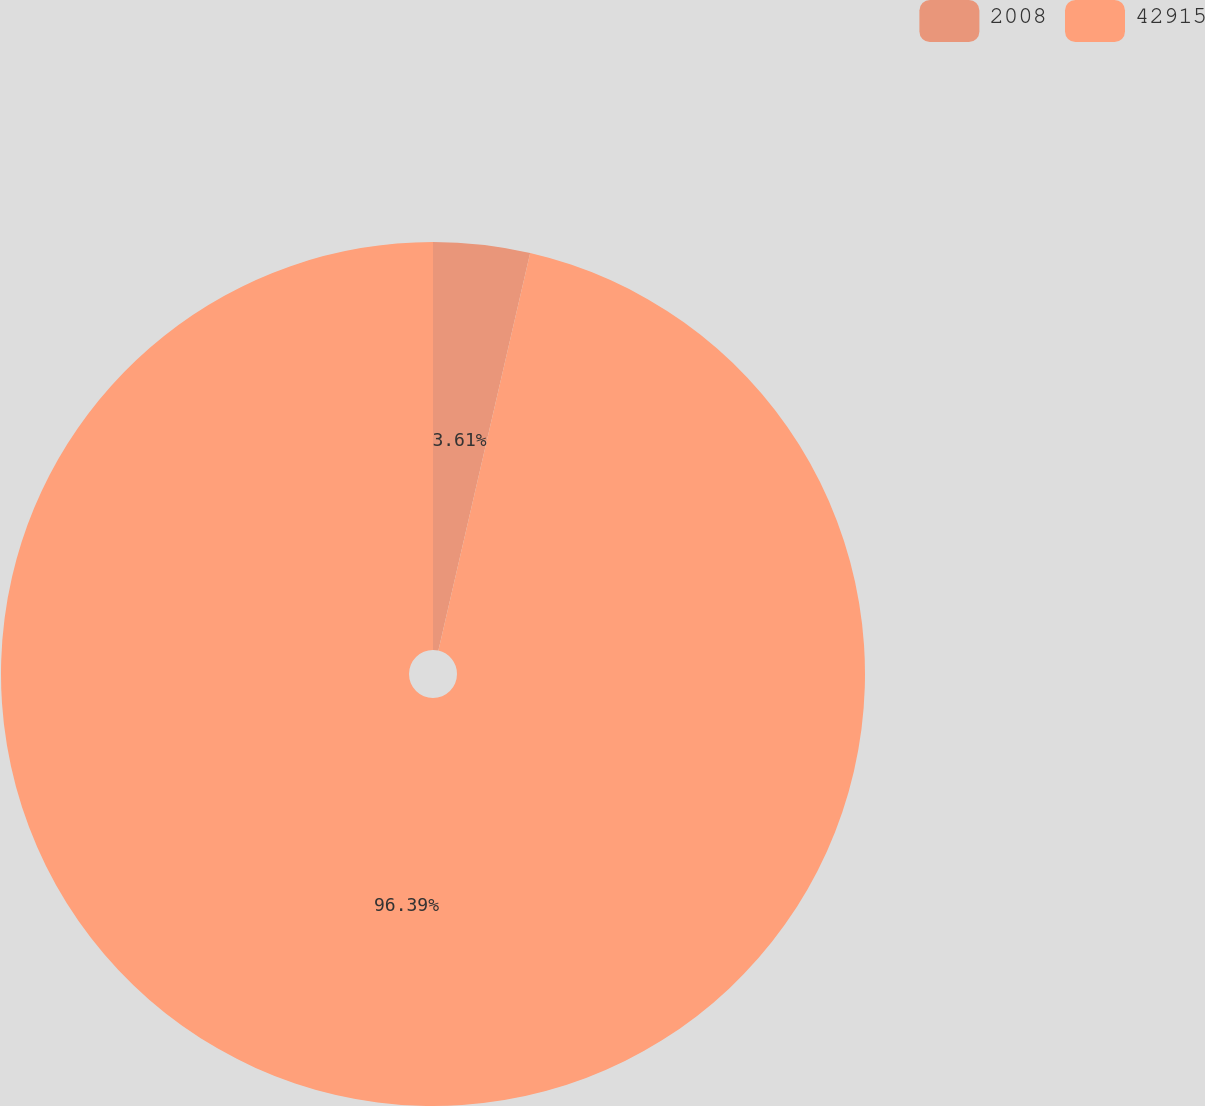Convert chart to OTSL. <chart><loc_0><loc_0><loc_500><loc_500><pie_chart><fcel>2008<fcel>42915<nl><fcel>3.61%<fcel>96.39%<nl></chart> 